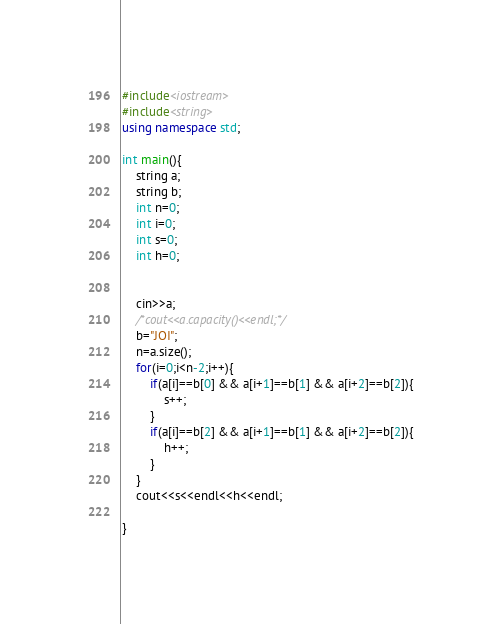<code> <loc_0><loc_0><loc_500><loc_500><_C++_>#include<iostream>
#include<string>
using namespace std;

int main(){
	string a;
	string b;
	int n=0;
	int i=0;
	int s=0;
	int h=0;
	
	
	cin>>a;
	/*cout<<a.capacity()<<endl;*/
	b="JOI";                                                       
	n=a.size();
	for(i=0;i<n-2;i++){
		if(a[i]==b[0] && a[i+1]==b[1] && a[i+2]==b[2]){
			s++;
		}
		if(a[i]==b[2] && a[i+1]==b[1] && a[i+2]==b[2]){
			h++;
		}
	}
	cout<<s<<endl<<h<<endl;
	
}</code> 